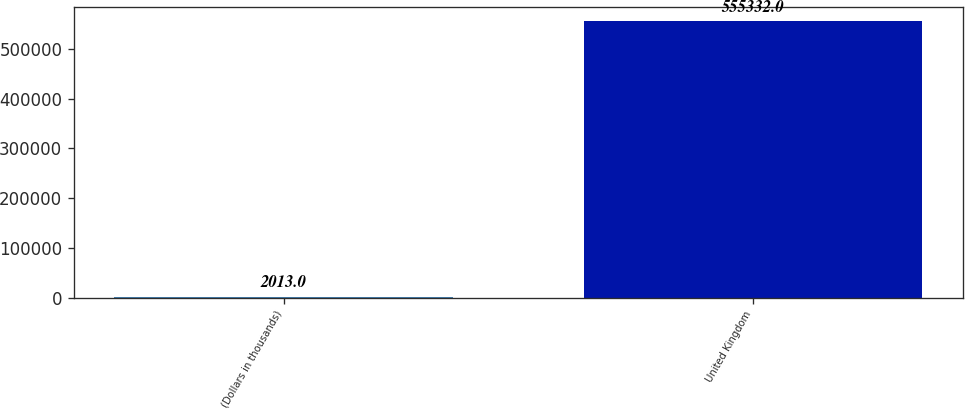Convert chart to OTSL. <chart><loc_0><loc_0><loc_500><loc_500><bar_chart><fcel>(Dollars in thousands)<fcel>United Kingdom<nl><fcel>2013<fcel>555332<nl></chart> 